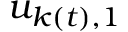Convert formula to latex. <formula><loc_0><loc_0><loc_500><loc_500>u _ { k ( t ) , 1 }</formula> 